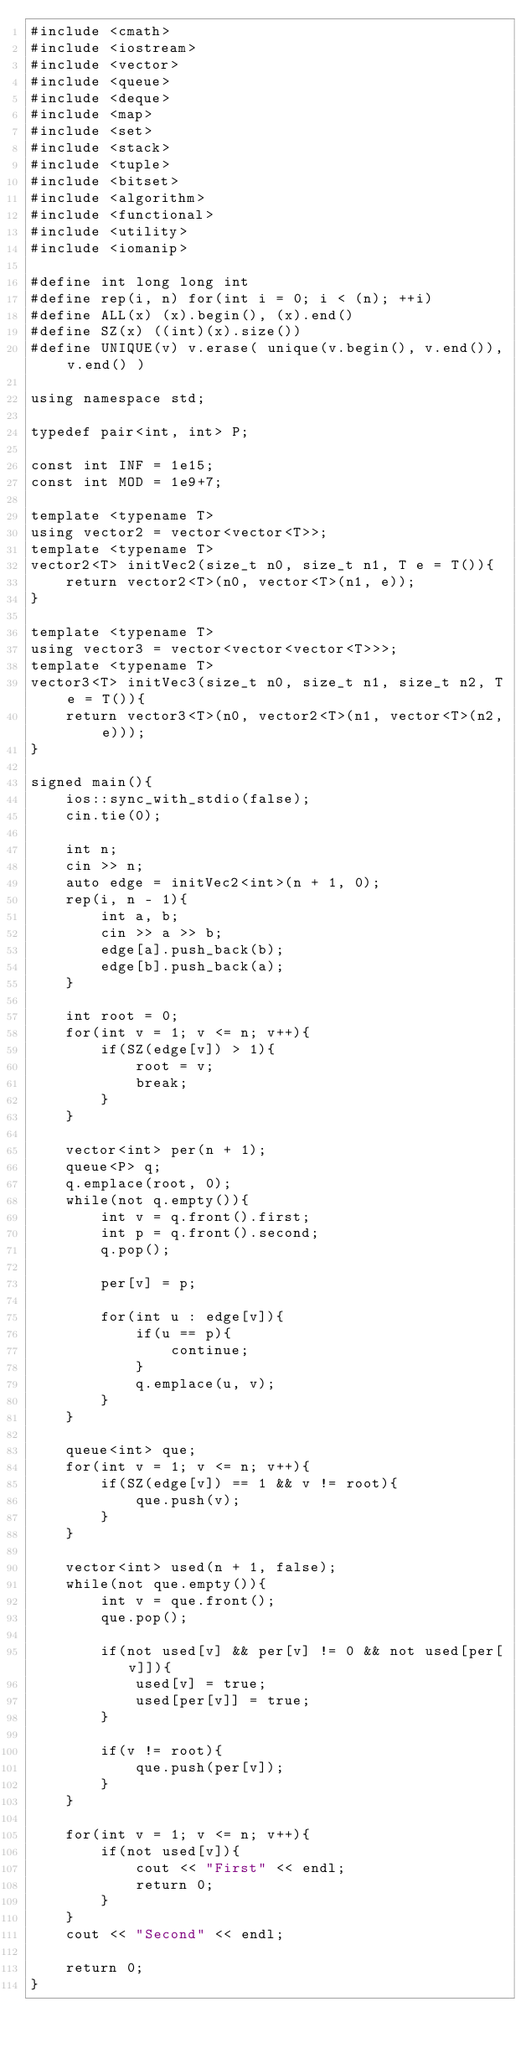Convert code to text. <code><loc_0><loc_0><loc_500><loc_500><_C++_>#include <cmath>
#include <iostream>
#include <vector>
#include <queue>
#include <deque>
#include <map>
#include <set>
#include <stack>
#include <tuple>
#include <bitset>
#include <algorithm>
#include <functional>
#include <utility>
#include <iomanip>

#define int long long int
#define rep(i, n) for(int i = 0; i < (n); ++i)
#define ALL(x) (x).begin(), (x).end()
#define SZ(x) ((int)(x).size())
#define UNIQUE(v) v.erase( unique(v.begin(), v.end()), v.end() )

using namespace std;

typedef pair<int, int> P;

const int INF = 1e15;
const int MOD = 1e9+7;

template <typename T>
using vector2 = vector<vector<T>>;
template <typename T>
vector2<T> initVec2(size_t n0, size_t n1, T e = T()){
    return vector2<T>(n0, vector<T>(n1, e));
}

template <typename T>
using vector3 = vector<vector<vector<T>>>;
template <typename T>
vector3<T> initVec3(size_t n0, size_t n1, size_t n2, T e = T()){
    return vector3<T>(n0, vector2<T>(n1, vector<T>(n2, e)));
}

signed main(){
    ios::sync_with_stdio(false);
    cin.tie(0);

    int n;
    cin >> n;
    auto edge = initVec2<int>(n + 1, 0);
    rep(i, n - 1){
        int a, b;
        cin >> a >> b;
        edge[a].push_back(b);
        edge[b].push_back(a);
    }

    int root = 0;
    for(int v = 1; v <= n; v++){
        if(SZ(edge[v]) > 1){
            root = v;
            break;
        }
    }

    vector<int> per(n + 1);
    queue<P> q;
    q.emplace(root, 0);
    while(not q.empty()){
        int v = q.front().first;
        int p = q.front().second;
        q.pop();

        per[v] = p;

        for(int u : edge[v]){
            if(u == p){
                continue;
            }
            q.emplace(u, v);
        }
    }

    queue<int> que;
    for(int v = 1; v <= n; v++){
        if(SZ(edge[v]) == 1 && v != root){
            que.push(v);
        }
    }

    vector<int> used(n + 1, false);
    while(not que.empty()){
        int v = que.front();
        que.pop();

        if(not used[v] && per[v] != 0 && not used[per[v]]){
            used[v] = true;
            used[per[v]] = true;
        }

        if(v != root){
            que.push(per[v]);
        }
    }

    for(int v = 1; v <= n; v++){
        if(not used[v]){
            cout << "First" << endl;
            return 0;
        }
    }
    cout << "Second" << endl;

    return 0;
}
</code> 